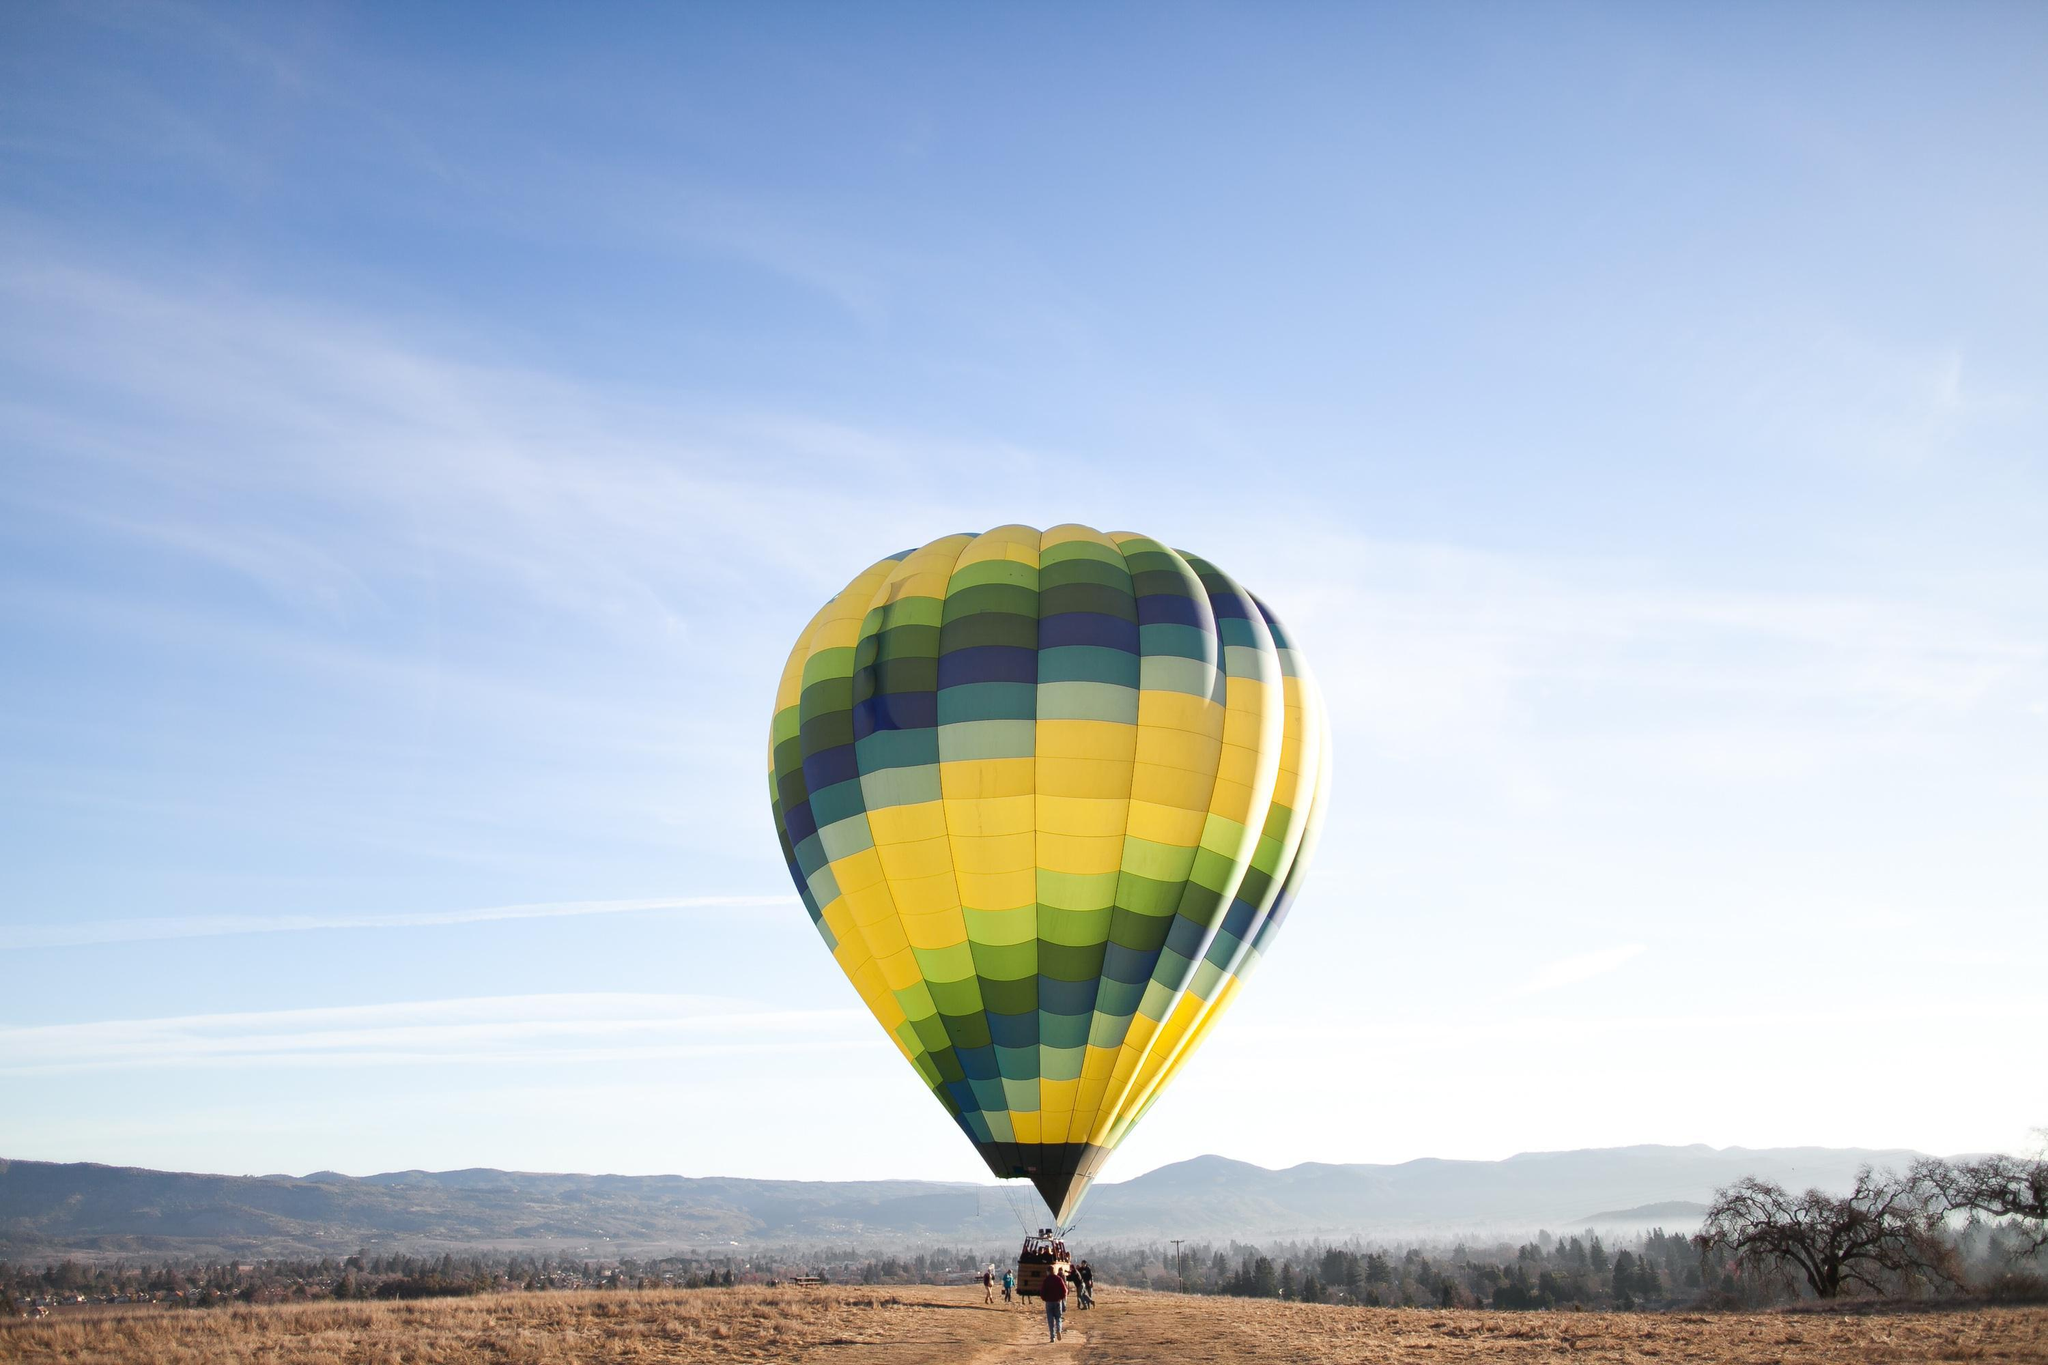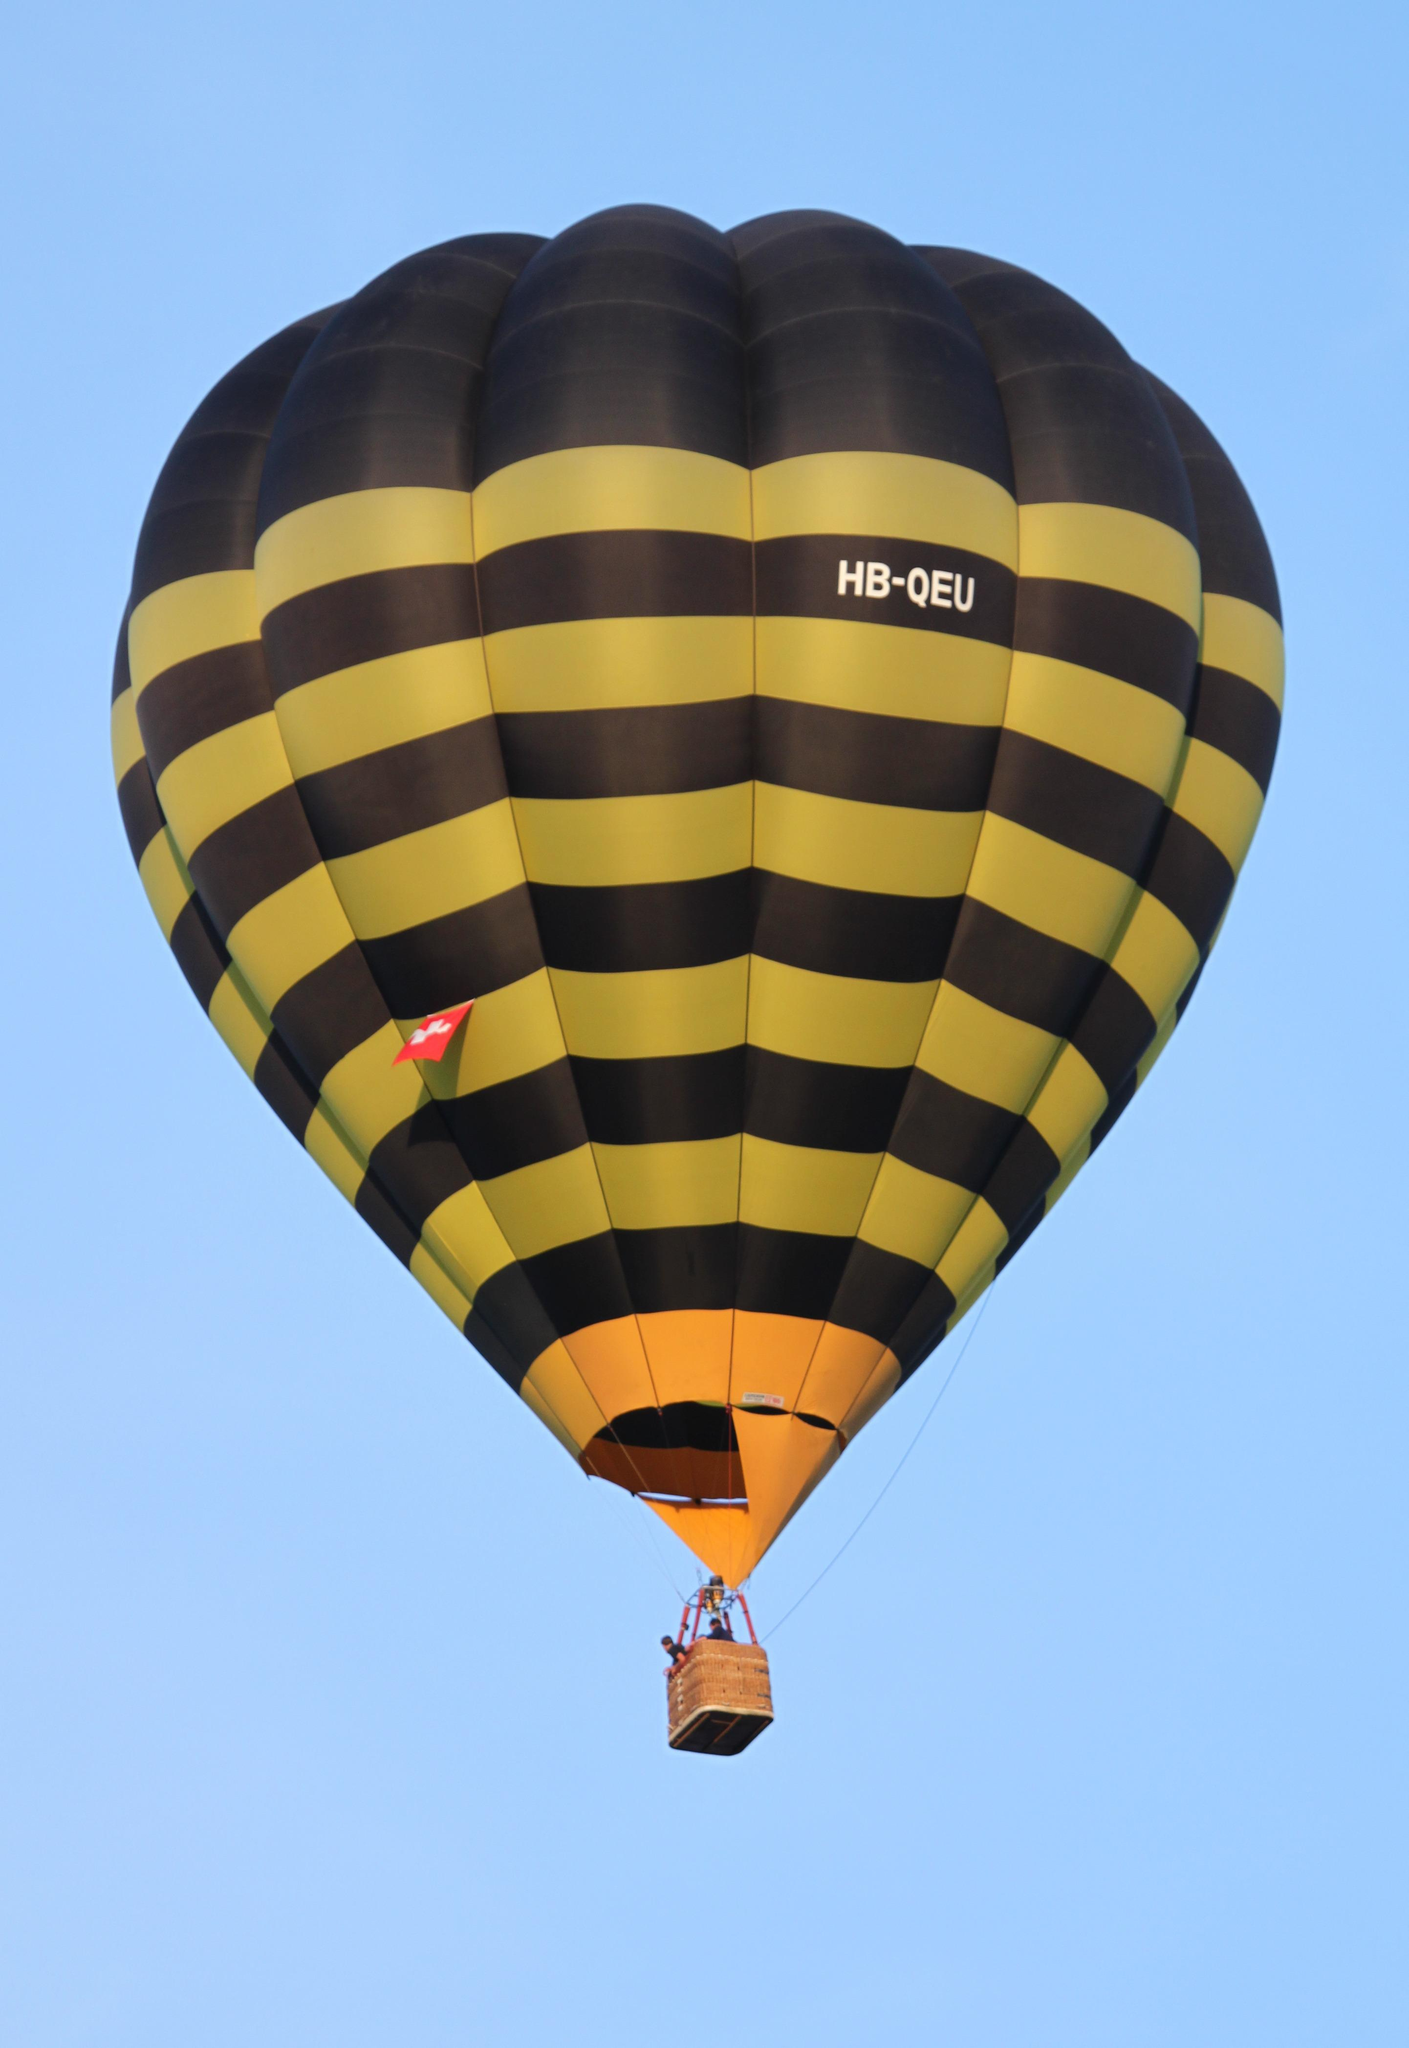The first image is the image on the left, the second image is the image on the right. Considering the images on both sides, is "No images show balloons against blue sky." valid? Answer yes or no. No. 